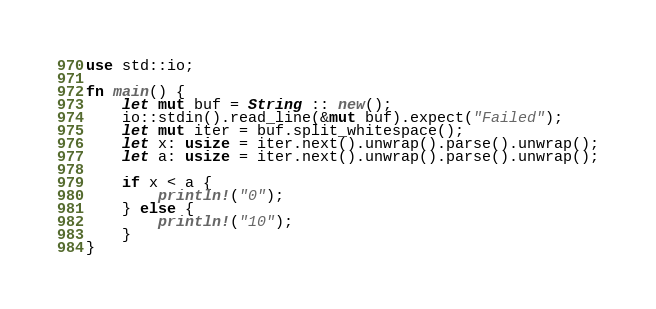Convert code to text. <code><loc_0><loc_0><loc_500><loc_500><_Rust_>use std::io;

fn main() {
    let mut buf = String :: new();
    io::stdin().read_line(&mut buf).expect("Failed");
    let mut iter = buf.split_whitespace();
    let x: usize = iter.next().unwrap().parse().unwrap();
    let a: usize = iter.next().unwrap().parse().unwrap();

    if x < a {
        println!("0");
    } else {
        println!("10");
    }
}
</code> 